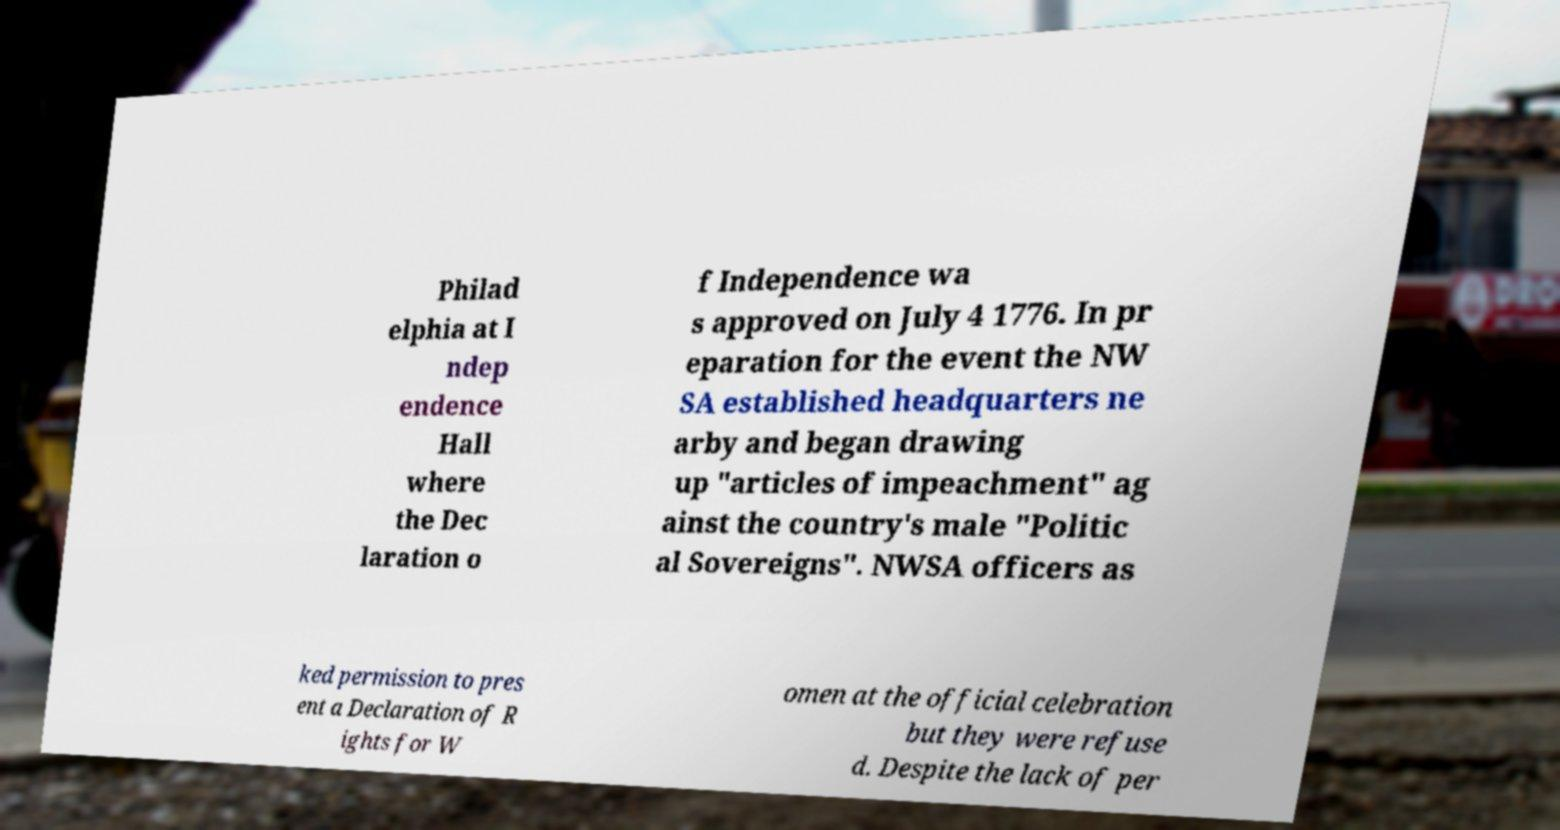Can you read and provide the text displayed in the image?This photo seems to have some interesting text. Can you extract and type it out for me? Philad elphia at I ndep endence Hall where the Dec laration o f Independence wa s approved on July 4 1776. In pr eparation for the event the NW SA established headquarters ne arby and began drawing up "articles of impeachment" ag ainst the country's male "Politic al Sovereigns". NWSA officers as ked permission to pres ent a Declaration of R ights for W omen at the official celebration but they were refuse d. Despite the lack of per 